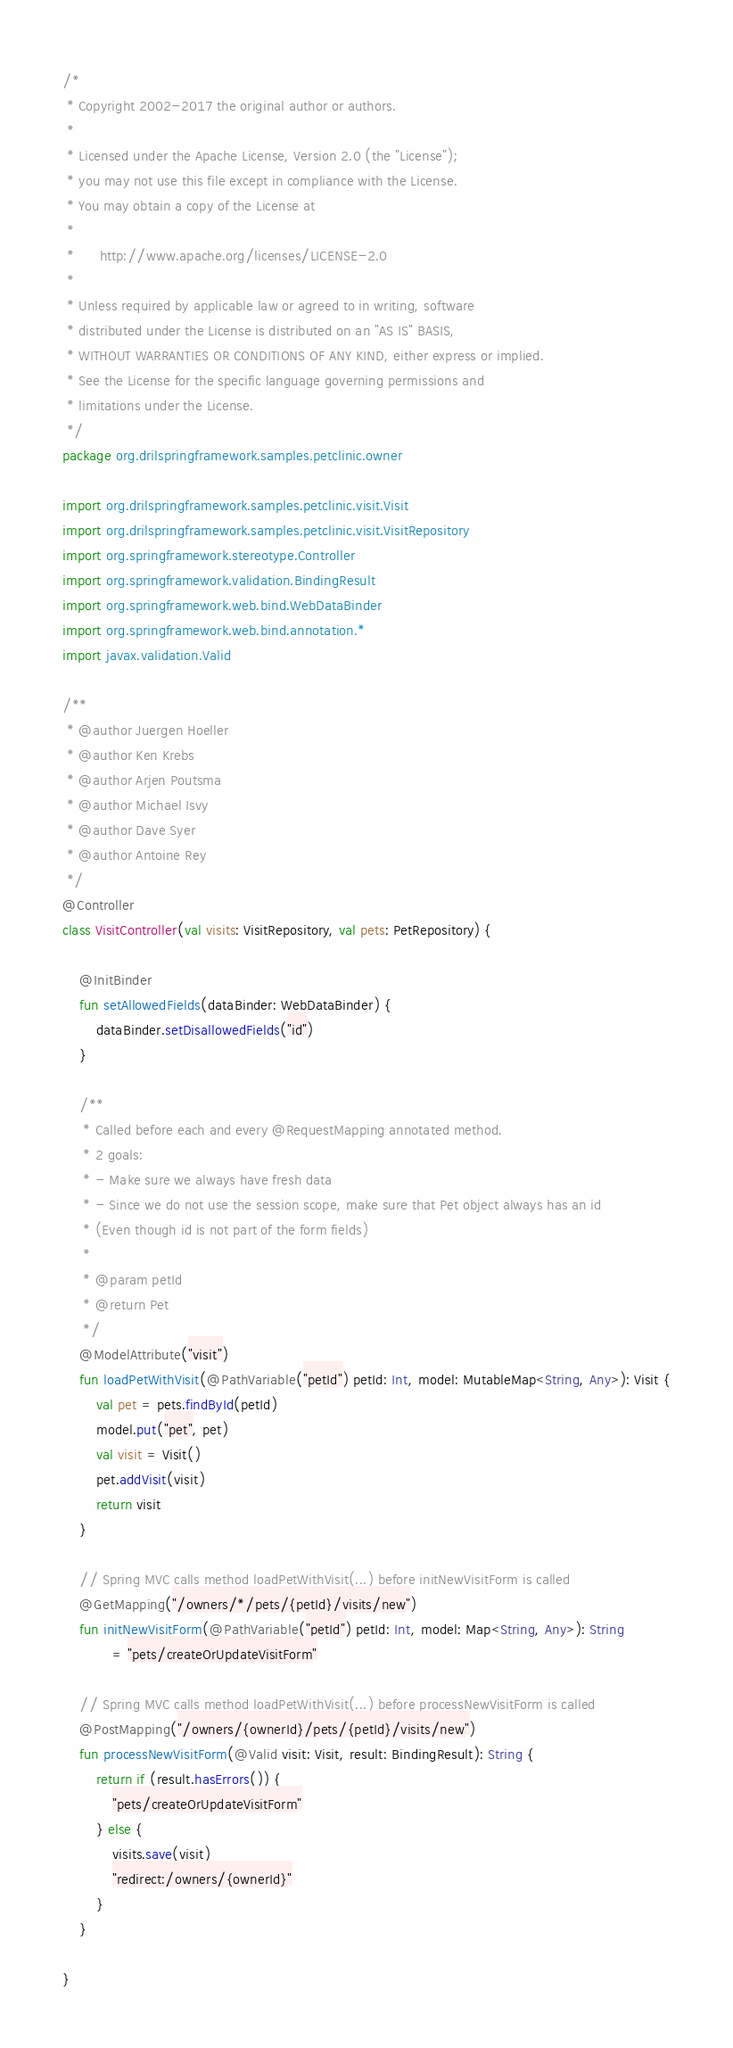Convert code to text. <code><loc_0><loc_0><loc_500><loc_500><_Kotlin_>/*
 * Copyright 2002-2017 the original author or authors.
 *
 * Licensed under the Apache License, Version 2.0 (the "License");
 * you may not use this file except in compliance with the License.
 * You may obtain a copy of the License at
 *
 *      http://www.apache.org/licenses/LICENSE-2.0
 *
 * Unless required by applicable law or agreed to in writing, software
 * distributed under the License is distributed on an "AS IS" BASIS,
 * WITHOUT WARRANTIES OR CONDITIONS OF ANY KIND, either express or implied.
 * See the License for the specific language governing permissions and
 * limitations under the License.
 */
package org.drilspringframework.samples.petclinic.owner

import org.drilspringframework.samples.petclinic.visit.Visit
import org.drilspringframework.samples.petclinic.visit.VisitRepository
import org.springframework.stereotype.Controller
import org.springframework.validation.BindingResult
import org.springframework.web.bind.WebDataBinder
import org.springframework.web.bind.annotation.*
import javax.validation.Valid

/**
 * @author Juergen Hoeller
 * @author Ken Krebs
 * @author Arjen Poutsma
 * @author Michael Isvy
 * @author Dave Syer
 * @author Antoine Rey
 */
@Controller
class VisitController(val visits: VisitRepository, val pets: PetRepository) {

    @InitBinder
    fun setAllowedFields(dataBinder: WebDataBinder) {
        dataBinder.setDisallowedFields("id")
    }

    /**
     * Called before each and every @RequestMapping annotated method.
     * 2 goals:
     * - Make sure we always have fresh data
     * - Since we do not use the session scope, make sure that Pet object always has an id
     * (Even though id is not part of the form fields)
     *
     * @param petId
     * @return Pet
     */
    @ModelAttribute("visit")
    fun loadPetWithVisit(@PathVariable("petId") petId: Int, model: MutableMap<String, Any>): Visit {
        val pet = pets.findById(petId)
        model.put("pet", pet)
        val visit = Visit()
        pet.addVisit(visit)
        return visit
    }

    // Spring MVC calls method loadPetWithVisit(...) before initNewVisitForm is called
    @GetMapping("/owners/*/pets/{petId}/visits/new")
    fun initNewVisitForm(@PathVariable("petId") petId: Int, model: Map<String, Any>): String
            = "pets/createOrUpdateVisitForm"

    // Spring MVC calls method loadPetWithVisit(...) before processNewVisitForm is called
    @PostMapping("/owners/{ownerId}/pets/{petId}/visits/new")
    fun processNewVisitForm(@Valid visit: Visit, result: BindingResult): String {
        return if (result.hasErrors()) {
            "pets/createOrUpdateVisitForm"
        } else {
            visits.save(visit)
            "redirect:/owners/{ownerId}"
        }
    }

}
</code> 